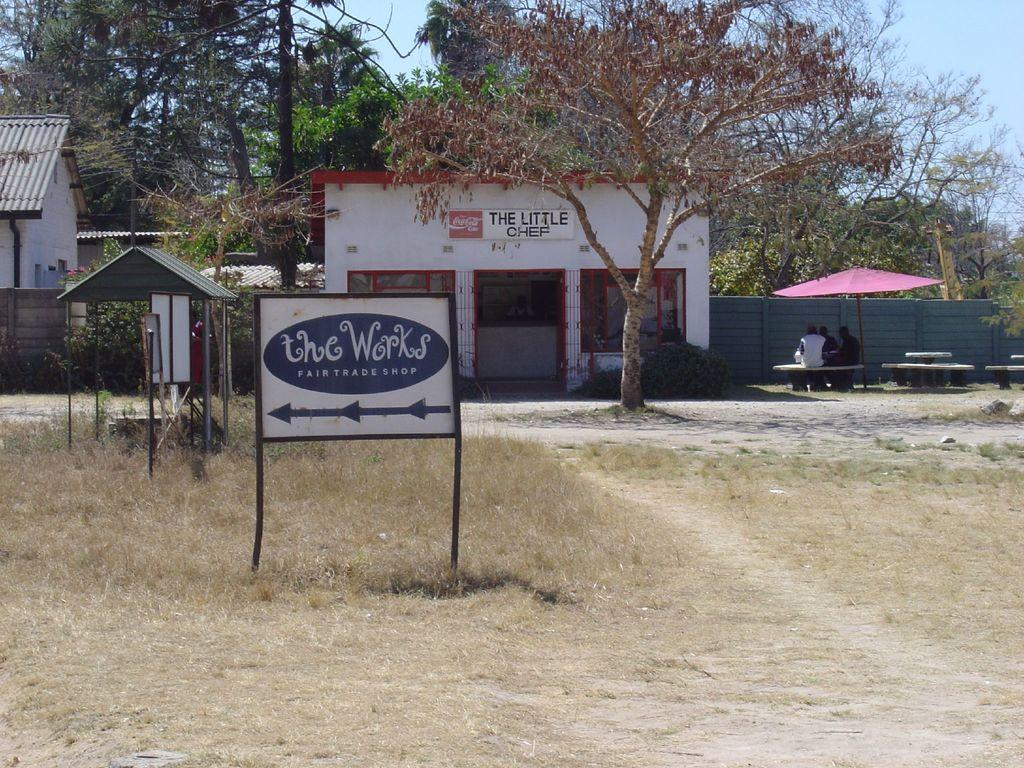What can be seen in the foreground of the image? There are name boards in the foreground of the image. What is visible in the background of the image? There are buildings, trees, a shed, an umbrella, and a person sitting under the umbrella in the background of the image. What is the condition of the sky in the image? The sky is visible in the background of the image. What is the price of the kitten at the market in the image? There is no kitten or market present in the image. What type of price is listed on the name boards in the image? The name boards in the image do not display any prices. 